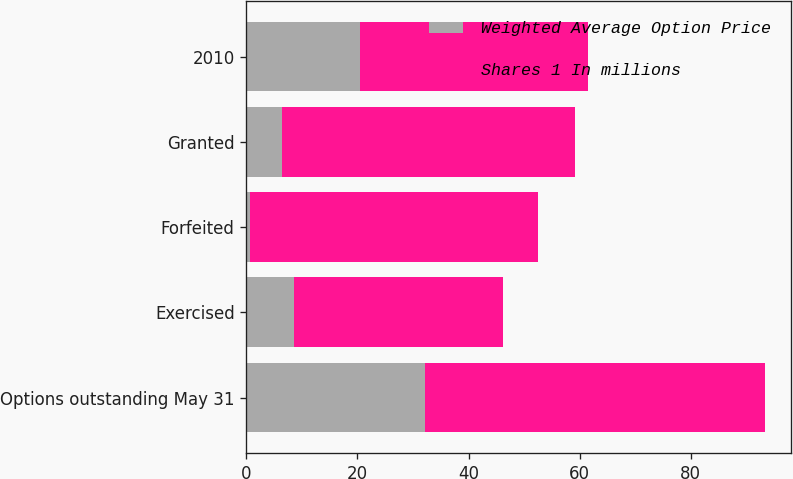Convert chart to OTSL. <chart><loc_0><loc_0><loc_500><loc_500><stacked_bar_chart><ecel><fcel>Options outstanding May 31<fcel>Exercised<fcel>Forfeited<fcel>Granted<fcel>2010<nl><fcel>Weighted Average Option Price<fcel>32.2<fcel>8.6<fcel>0.6<fcel>6.4<fcel>20.4<nl><fcel>Shares 1 In millions<fcel>61.18<fcel>37.64<fcel>51.92<fcel>52.79<fcel>41.16<nl></chart> 